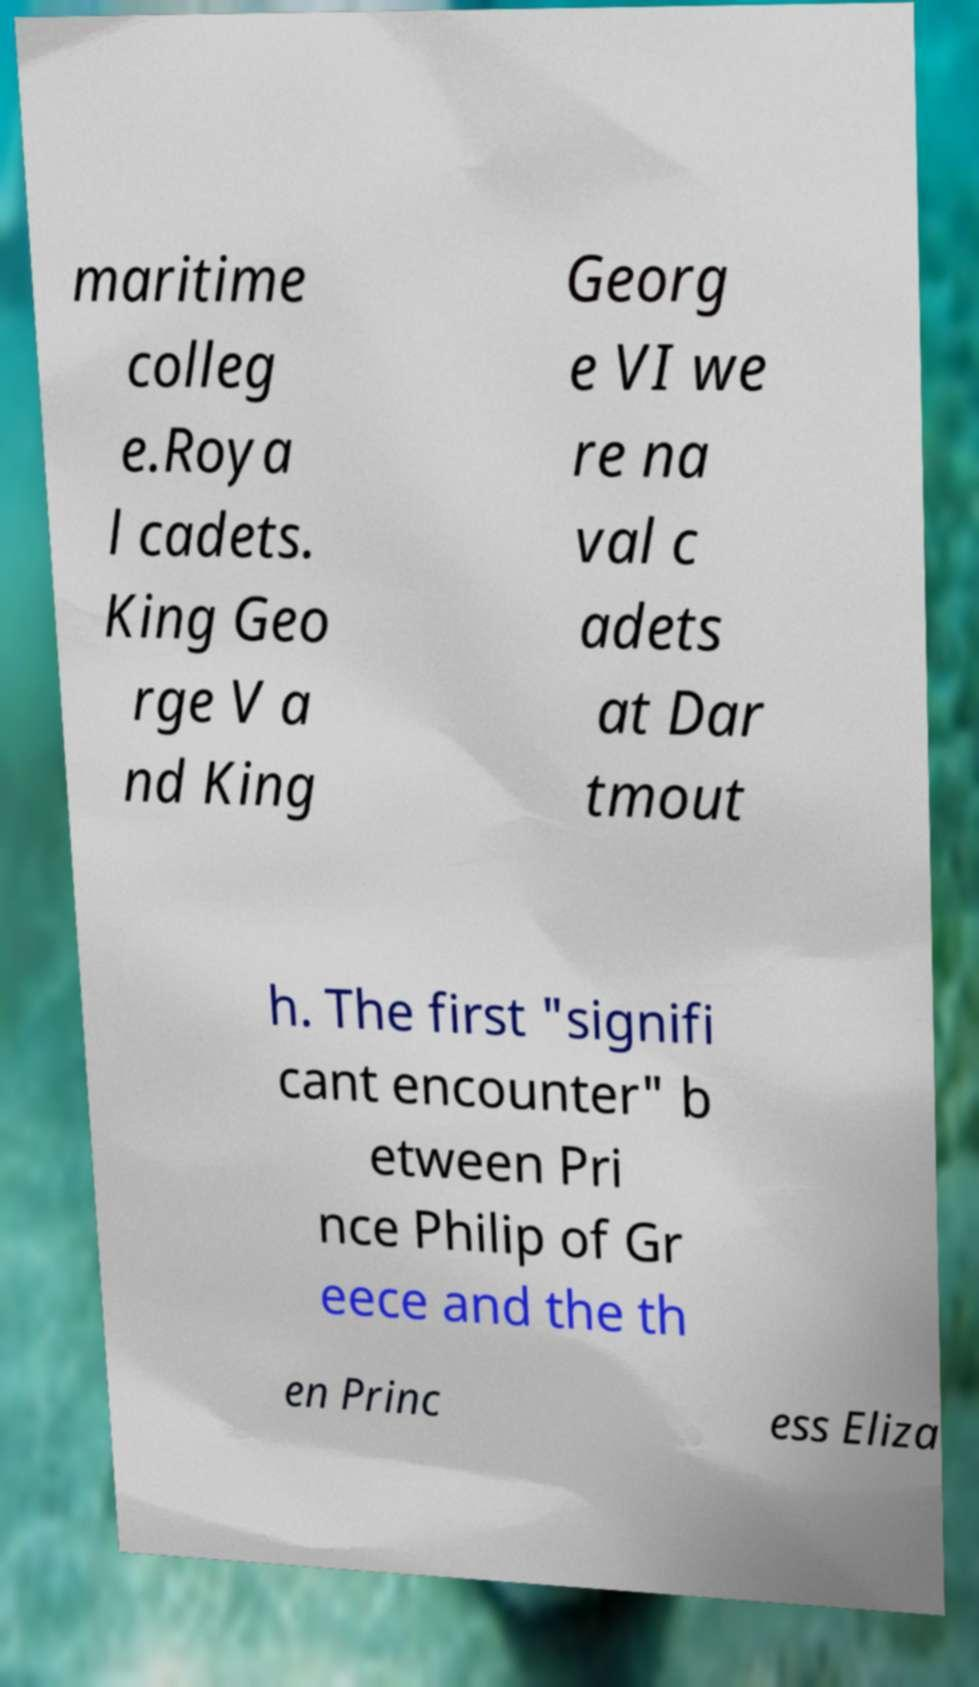I need the written content from this picture converted into text. Can you do that? maritime colleg e.Roya l cadets. King Geo rge V a nd King Georg e VI we re na val c adets at Dar tmout h. The first "signifi cant encounter" b etween Pri nce Philip of Gr eece and the th en Princ ess Eliza 